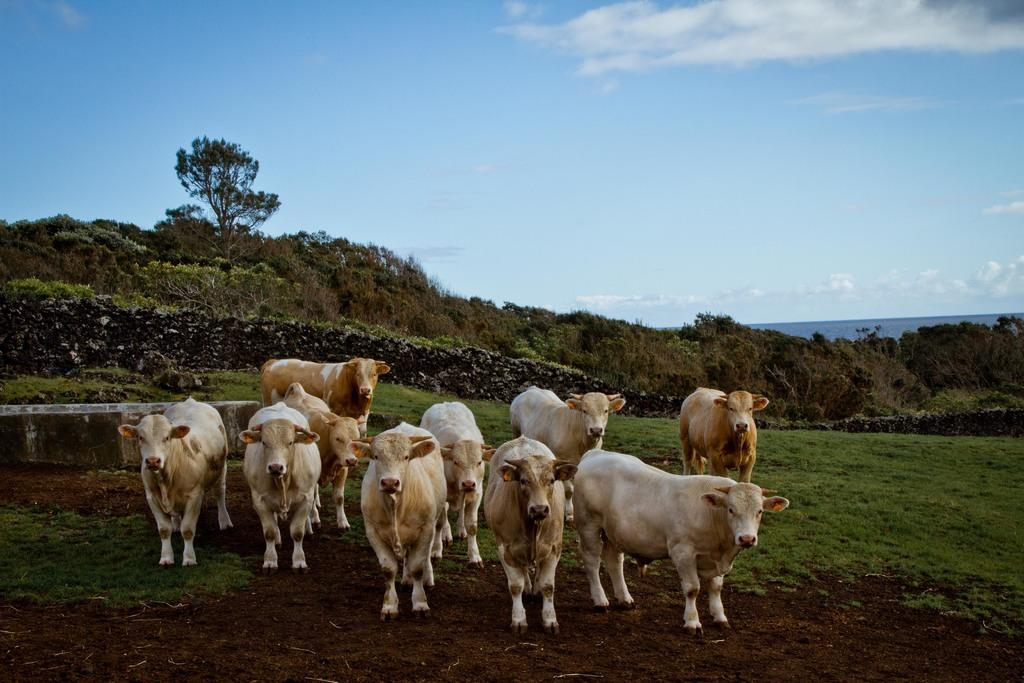What type of animals can be seen in the image? There are cows in the image. What type of vegetation is present in the image? There is grass in the image. What other natural elements can be seen in the image? There are trees in the image. What is visible in the background of the image? The sky is visible in the image, and clouds are present in the sky. What type of ice can be seen melting on the corn in the image? There is no ice or corn present in the image; it features cows, grass, trees, and a sky with clouds. 